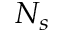Convert formula to latex. <formula><loc_0><loc_0><loc_500><loc_500>N _ { s }</formula> 